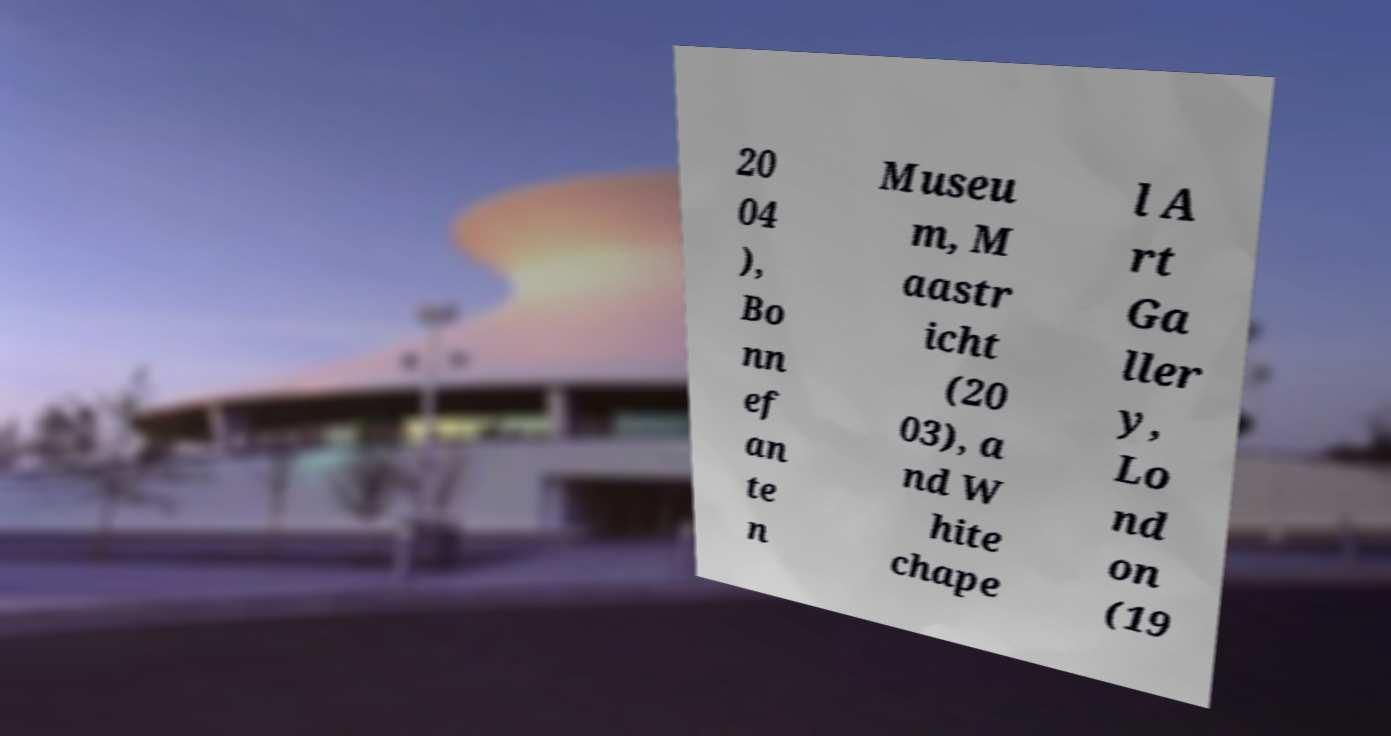I need the written content from this picture converted into text. Can you do that? 20 04 ), Bo nn ef an te n Museu m, M aastr icht (20 03), a nd W hite chape l A rt Ga ller y, Lo nd on (19 